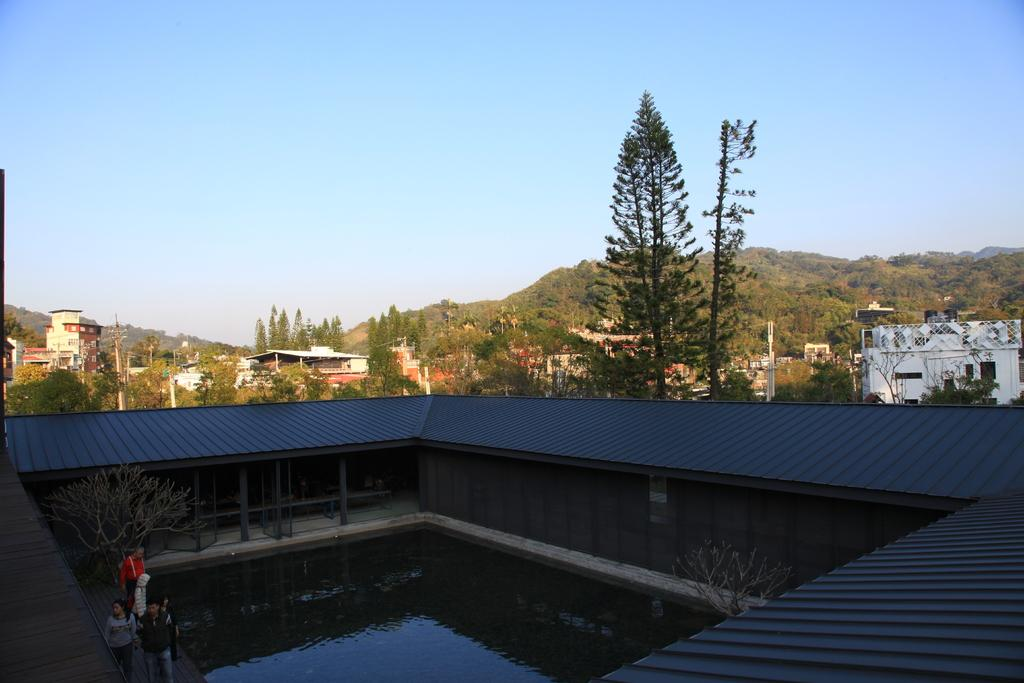What is the primary element present in the image? There is water in the image. Can you describe the people in the image? There is a group of people standing in the image. What type of natural environment can be seen in the image? There are trees and hills in the image. What type of structures are visible in the image? There are houses and poles in the image. What is visible in the background of the image? The sky is visible in the background of the image. What type of ship can be seen sailing in the water in the image? There is no ship present in the image; it only features water, a group of people, trees, houses, poles, hills, and the sky. 